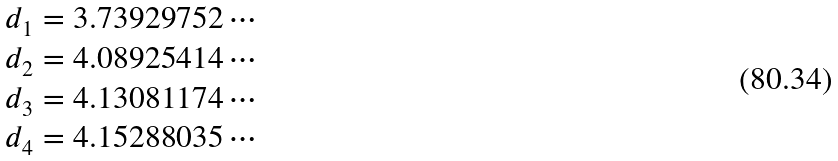Convert formula to latex. <formula><loc_0><loc_0><loc_500><loc_500>d _ { 1 } & = 3 . 7 3 9 2 9 7 5 2 \cdots \\ d _ { 2 } & = 4 . 0 8 9 2 5 4 1 4 \cdots \\ d _ { 3 } & = 4 . 1 3 0 8 1 1 7 4 \cdots \\ d _ { 4 } & = 4 . 1 5 2 8 8 0 3 5 \cdots</formula> 